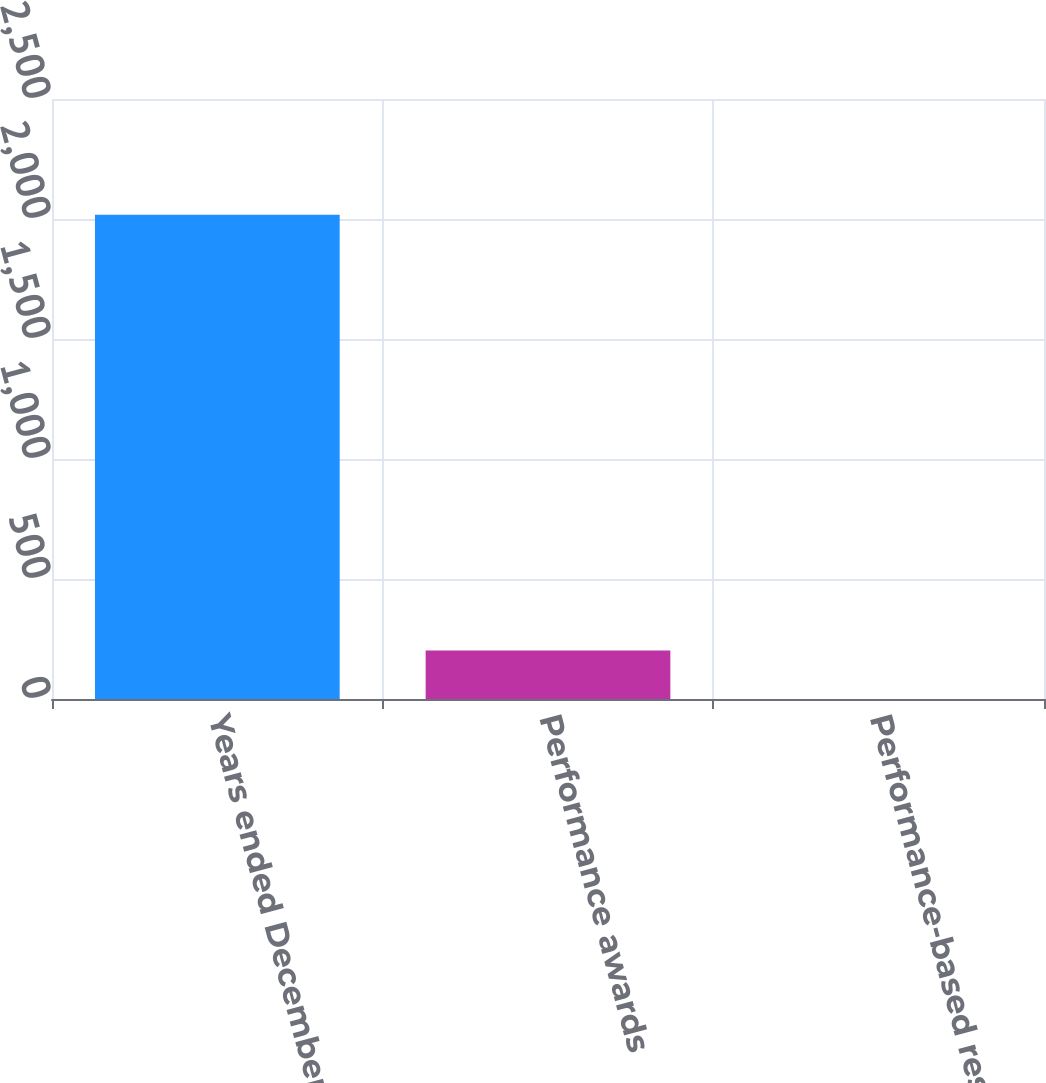Convert chart. <chart><loc_0><loc_0><loc_500><loc_500><bar_chart><fcel>Years ended December 31<fcel>Performance awards<fcel>Performance-based restricted<nl><fcel>2018<fcel>202.07<fcel>0.3<nl></chart> 